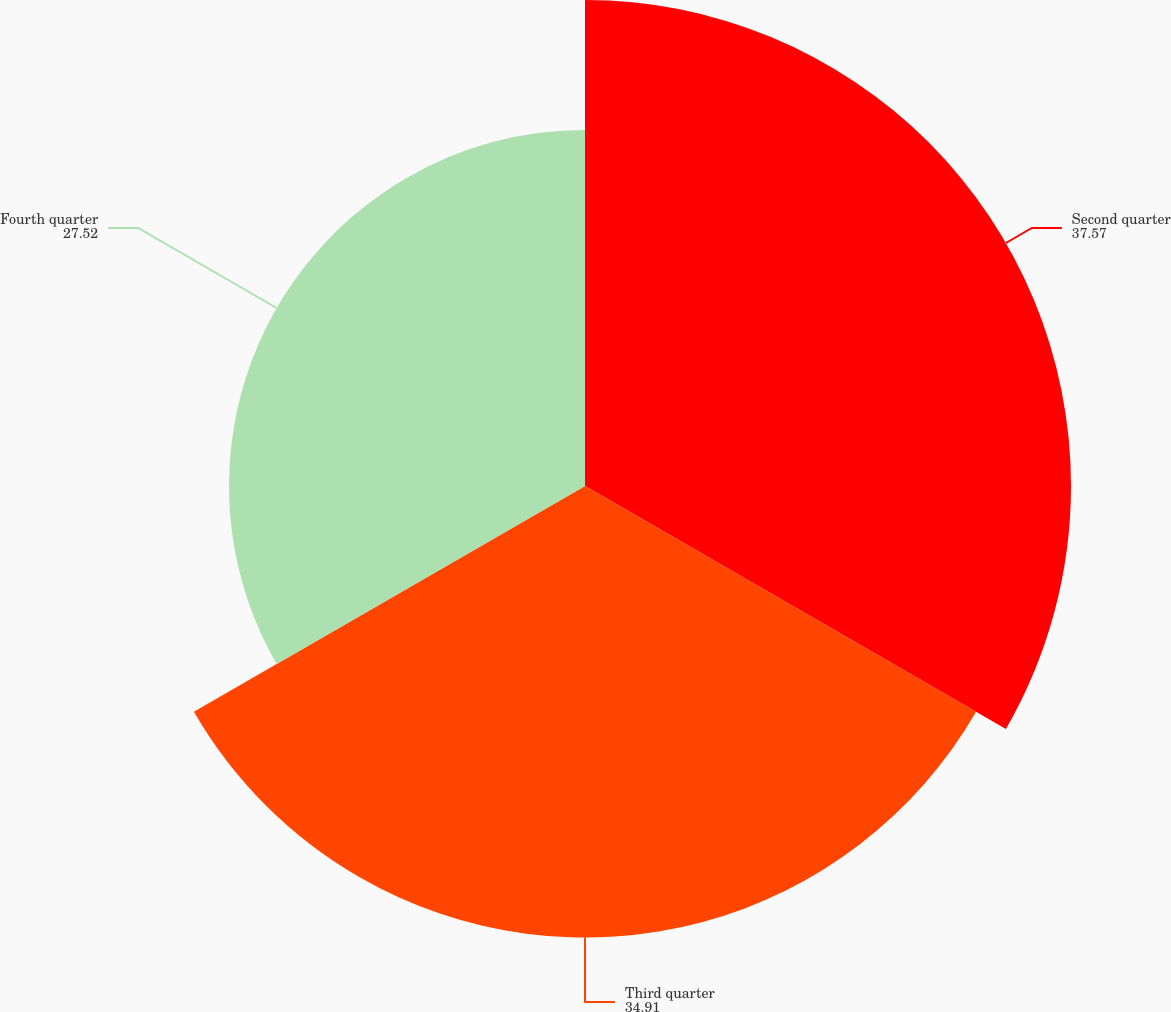Convert chart to OTSL. <chart><loc_0><loc_0><loc_500><loc_500><pie_chart><fcel>Second quarter<fcel>Third quarter<fcel>Fourth quarter<nl><fcel>37.57%<fcel>34.91%<fcel>27.52%<nl></chart> 